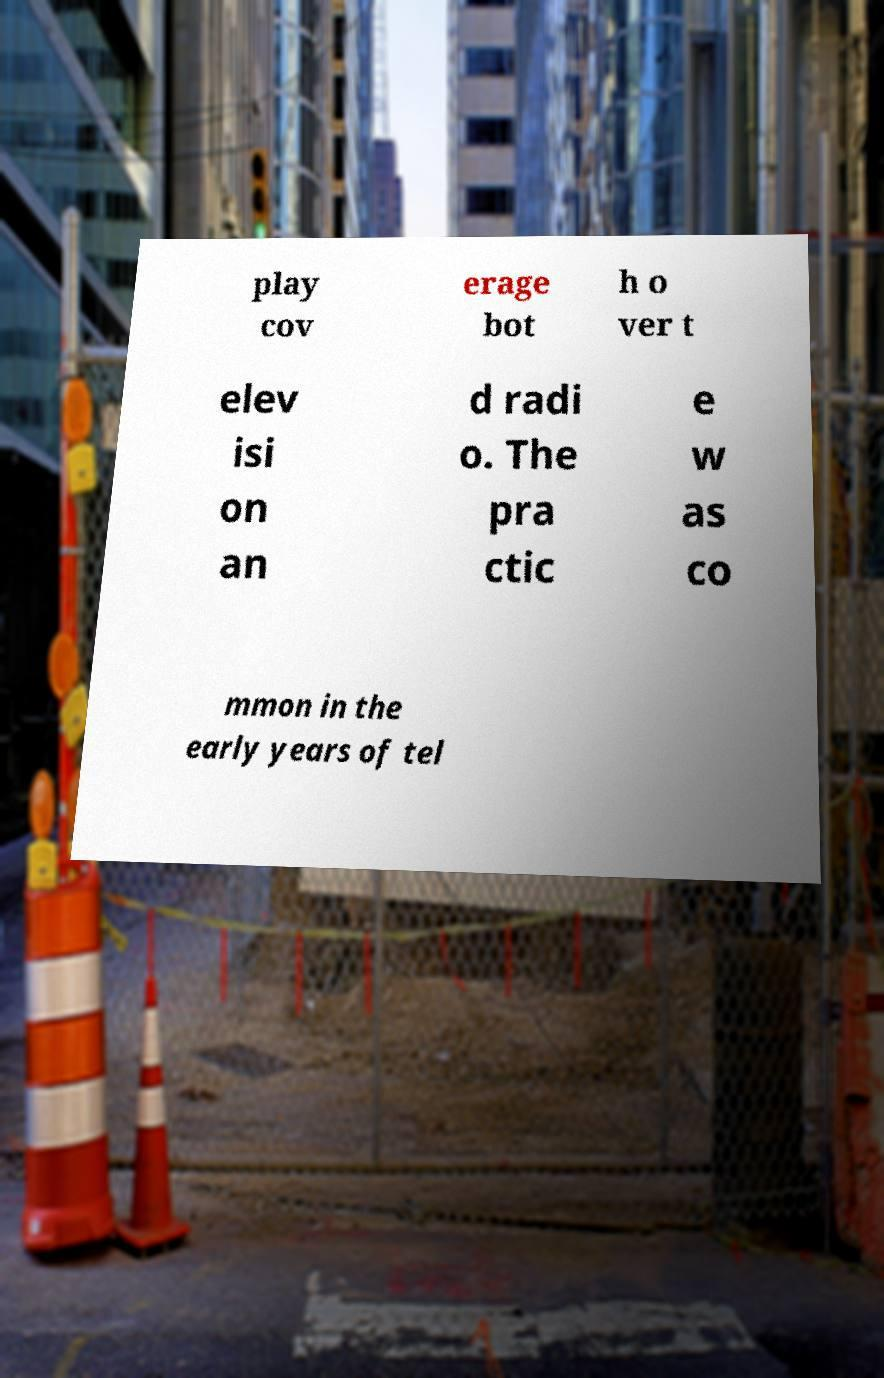Please read and relay the text visible in this image. What does it say? play cov erage bot h o ver t elev isi on an d radi o. The pra ctic e w as co mmon in the early years of tel 